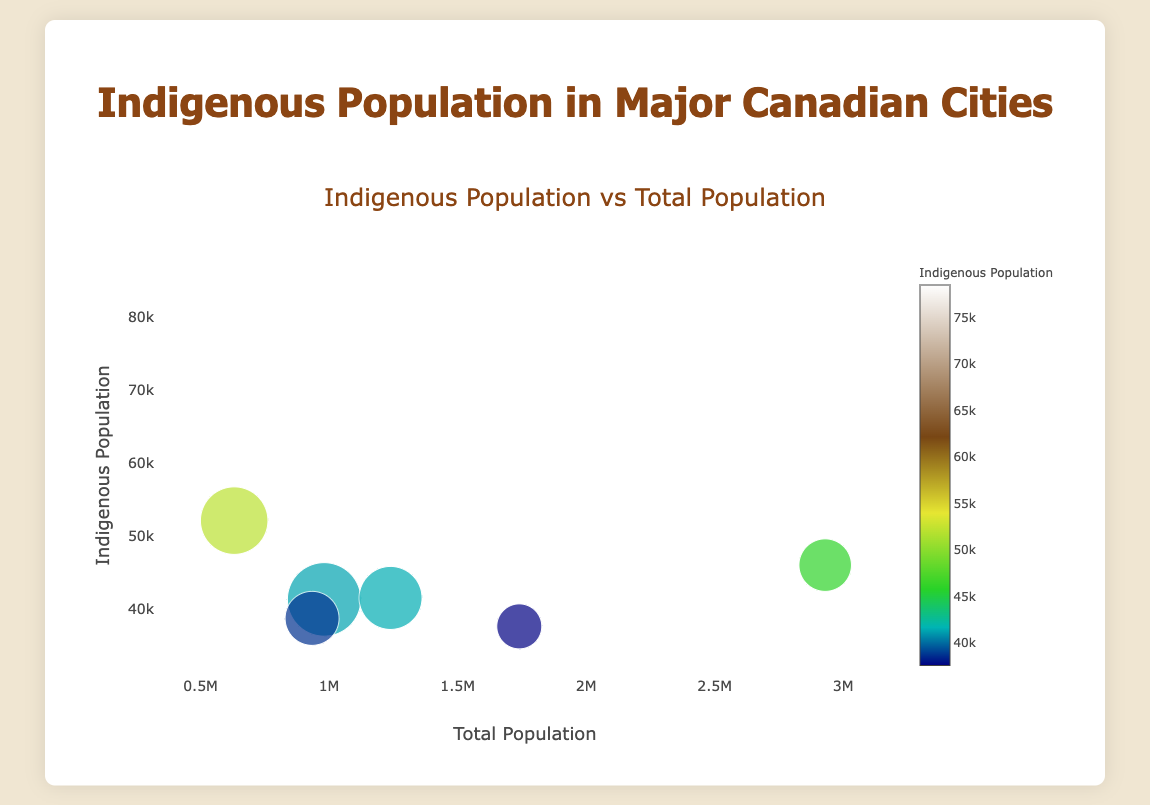Which city has the largest indigenous population? The largest indigenous population is denoted by the highest value on the y-axis. Winnipeg has the highest y-value indicating an indigenous population of 78,500.
Answer: Winnipeg Which city has the smallest indigenous population? The smallest indigenous population is denoted by the lowest value on the y-axis. Montreal has the lowest y-value indicating an indigenous population of 37,600.
Answer: Montreal What is the title of the plot? The title is usually placed at the top center of the plot. It is "Indigenous Population vs Total Population".
Answer: Indigenous Population vs Total Population Which city has the largest community size? Community sizes are represented by the size of the bubbles. The largest bubble size is for Winnipeg with a community size of 55.
Answer: Winnipeg How is the indigenous population represented in this plot? The indigenous population is represented on the y-axis and also via the color of the bubbles, darker shades likely indicate higher populations.
Answer: y-axis and bubble color Which cities have an indigenous population greater than 40,000 but less than 50,000? Filter all the y-axis values between 40,000 and 50,000; these correspond to the cities Edmonton, Calgary, and Toronto.
Answer: Edmonton, Calgary, Toronto What is the total population of the city with the largest indigenous community size? Identify the city with the largest community size, which is Winnipeg. Then locate its total population on the x-axis, which is 749,000.
Answer: 749,000 Which city has a greater indigenous population: Edmonton or Calgary? Compare the y-axis values for Edmonton (41,300) and Calgary (41,500). Calgary's value is slightly higher.
Answer: Calgary What does the size of the bubbles represent? The bubble size typically represents the community size as denoted in the marker size parameter. Larger bubbles indicate larger community sizes.
Answer: Community size What color scheme is used to represent the indigenous population? The plot uses a color scale called 'Earth', which ranges from light to dark colors, with darker colors representing higher indigenous populations.
Answer: Earth 